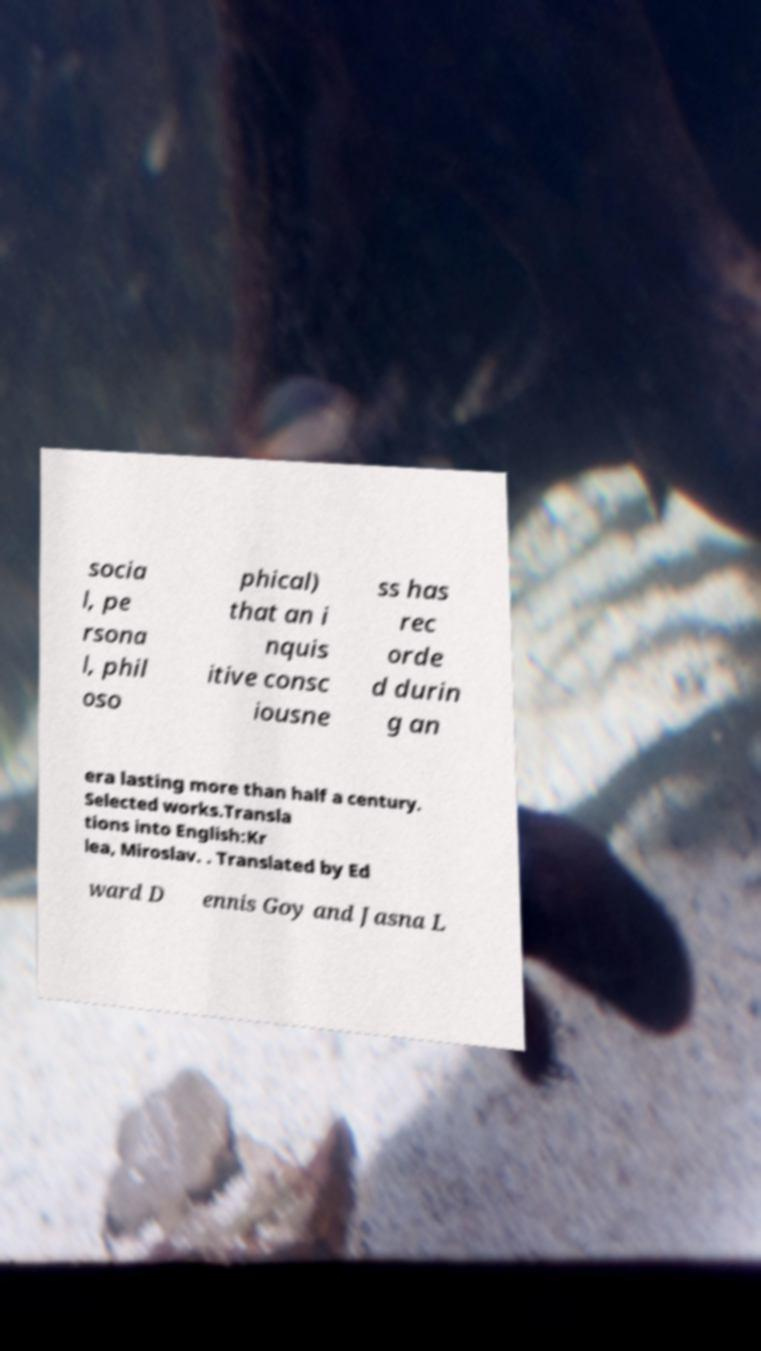Could you extract and type out the text from this image? socia l, pe rsona l, phil oso phical) that an i nquis itive consc iousne ss has rec orde d durin g an era lasting more than half a century. Selected works.Transla tions into English:Kr lea, Miroslav. . Translated by Ed ward D ennis Goy and Jasna L 